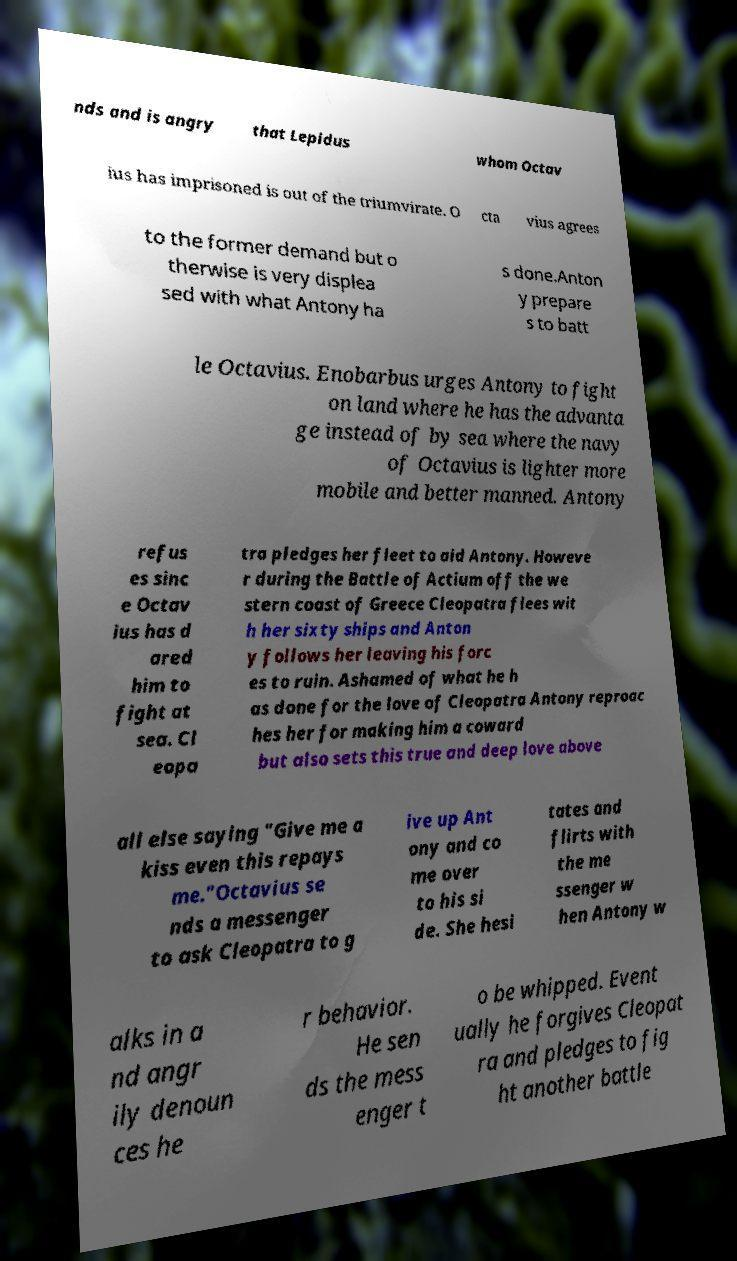Please identify and transcribe the text found in this image. nds and is angry that Lepidus whom Octav ius has imprisoned is out of the triumvirate. O cta vius agrees to the former demand but o therwise is very displea sed with what Antony ha s done.Anton y prepare s to batt le Octavius. Enobarbus urges Antony to fight on land where he has the advanta ge instead of by sea where the navy of Octavius is lighter more mobile and better manned. Antony refus es sinc e Octav ius has d ared him to fight at sea. Cl eopa tra pledges her fleet to aid Antony. Howeve r during the Battle of Actium off the we stern coast of Greece Cleopatra flees wit h her sixty ships and Anton y follows her leaving his forc es to ruin. Ashamed of what he h as done for the love of Cleopatra Antony reproac hes her for making him a coward but also sets this true and deep love above all else saying "Give me a kiss even this repays me."Octavius se nds a messenger to ask Cleopatra to g ive up Ant ony and co me over to his si de. She hesi tates and flirts with the me ssenger w hen Antony w alks in a nd angr ily denoun ces he r behavior. He sen ds the mess enger t o be whipped. Event ually he forgives Cleopat ra and pledges to fig ht another battle 